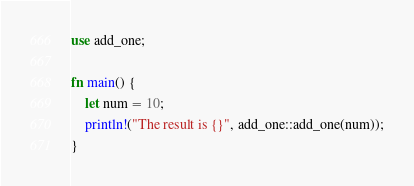<code> <loc_0><loc_0><loc_500><loc_500><_Rust_>use add_one;

fn main() {
    let num = 10;
    println!("The result is {}", add_one::add_one(num));
}
</code> 